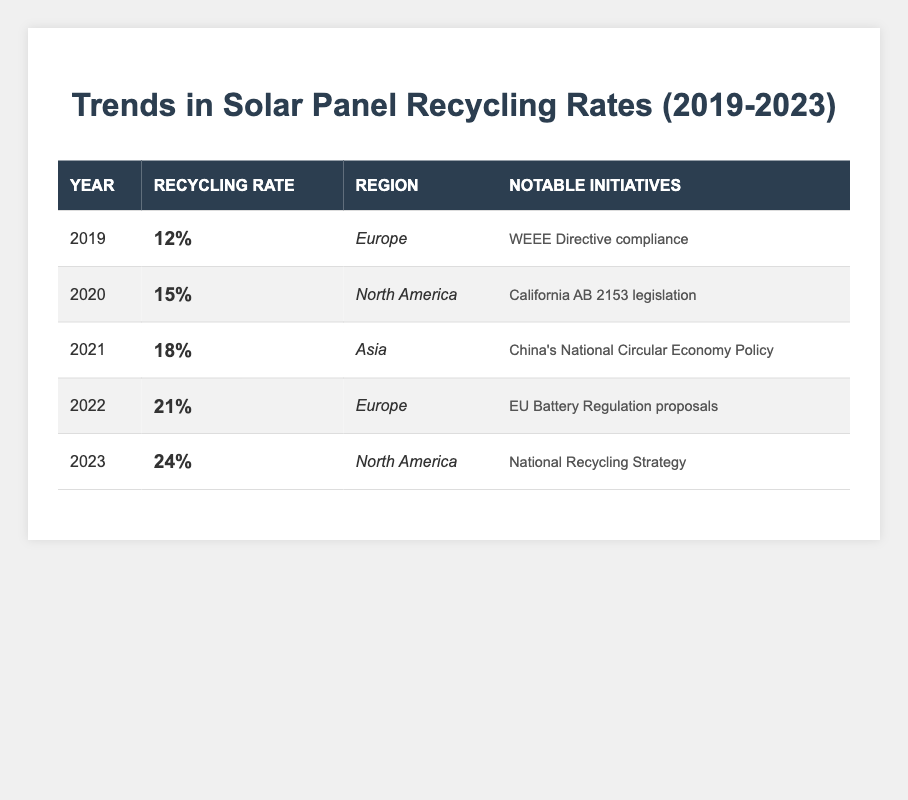What was the recycling rate in Europe in 2022? The recycling rate for Europe in 2022 is stated directly in the table as 21%.
Answer: 21% What notable initiative was mentioned for North America in 2023? The table specifies that the notable initiative for North America in 2023 is the "National Recycling Strategy."
Answer: National Recycling Strategy Which region had the highest recycling rate in 2021? According to the table, Asia had the highest recycling rate in 2021 at 18%.
Answer: Asia What is the difference in the recycling rate between 2019 and 2023? The recycling rate in 2019 was 12% and in 2023 it is 24%. To find the difference: 24% - 12% = 12%.
Answer: 12% Which year shows the highest increase in recycling rate compared to the previous year? To find the year with the highest increase, we compare: 2020 (15% - 12% = 3%), 2021 (18% - 15% = 3%), 2022 (21% - 18% = 3%), and 2023 (24% - 21% = 3%). Each year shows an increase of 3%, so there is no year with a higher increase than the others.
Answer: No year had a higher increase What is the average recycling rate from 2019 to 2023? The recycling rates for these years are: 12%, 15%, 18%, 21%, and 24%. To find the average: (12 + 15 + 18 + 21 + 24) / 5 = 90 / 5 = 18%.
Answer: 18% Was there any notable initiative related to recycling in Asia in 2021? The table states that in 2021, Asia's notable initiative was "China's National Circular Economy Policy."
Answer: Yes In which two years did Europe have notable initiatives regarding recycling? The table shows that noted initiatives in Europe occurred in 2019 (WEEE Directive compliance) and 2022 (EU Battery Regulation proposals).
Answer: 2019 and 2022 How much did the recycling rate increase in North America from 2020 to 2023? In 2020, North America's recycling rate was 15% and in 2023 it is 24%. The increase is calculated as: 24% - 15% = 9%.
Answer: 9% 